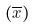<formula> <loc_0><loc_0><loc_500><loc_500>( \overline { x } )</formula> 